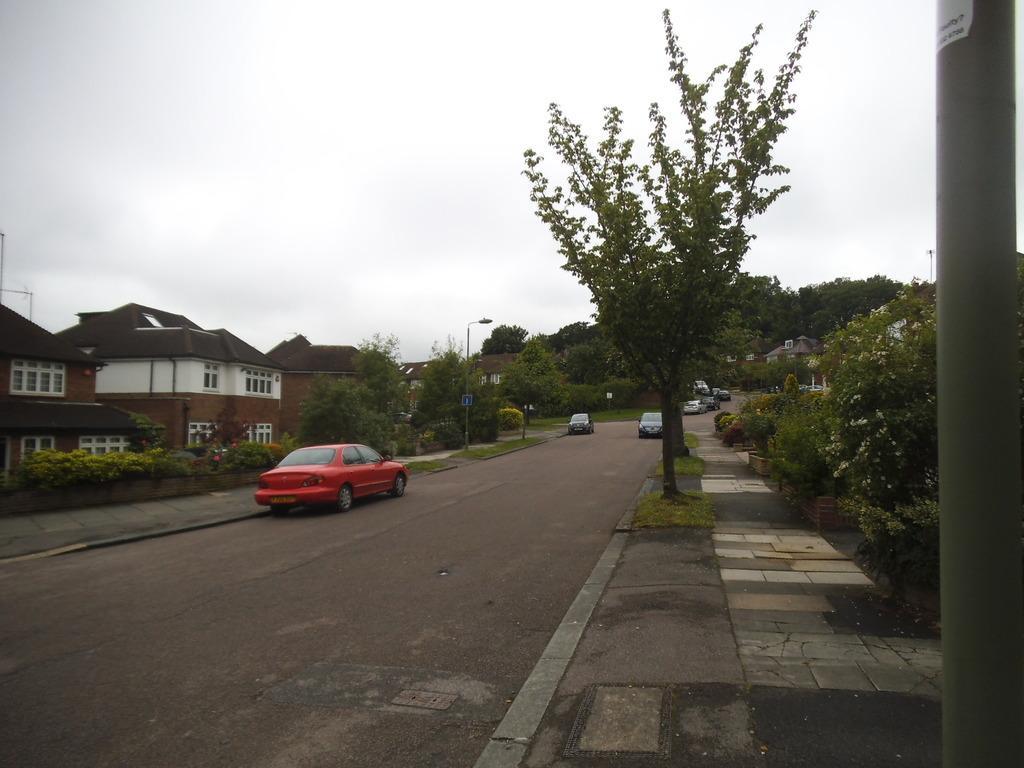Please provide a concise description of this image. In the center of the image there are cars on the road. On both right and left side of the image there are plants and flowers. There are street lights. In the background of the image there are buildings, trees and sky. 